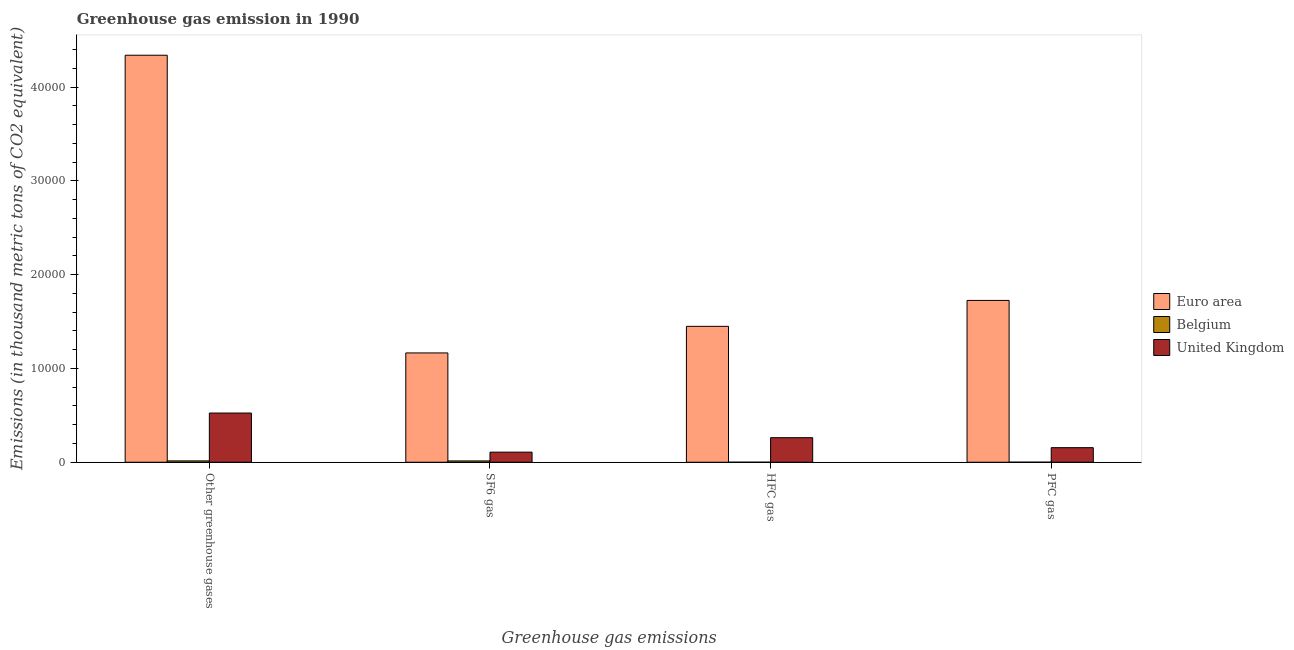How many different coloured bars are there?
Provide a succinct answer. 3. Are the number of bars on each tick of the X-axis equal?
Provide a succinct answer. Yes. How many bars are there on the 2nd tick from the left?
Your answer should be compact. 3. What is the label of the 1st group of bars from the left?
Your answer should be very brief. Other greenhouse gases. What is the emission of greenhouse gases in Euro area?
Ensure brevity in your answer.  4.34e+04. Across all countries, what is the maximum emission of hfc gas?
Provide a short and direct response. 1.45e+04. Across all countries, what is the minimum emission of greenhouse gases?
Make the answer very short. 141.9. In which country was the emission of greenhouse gases minimum?
Provide a short and direct response. Belgium. What is the total emission of sf6 gas in the graph?
Offer a very short reply. 1.29e+04. What is the difference between the emission of greenhouse gases in United Kingdom and that in Belgium?
Offer a very short reply. 5102.3. What is the difference between the emission of hfc gas in United Kingdom and the emission of pfc gas in Euro area?
Give a very brief answer. -1.46e+04. What is the average emission of greenhouse gases per country?
Your answer should be compact. 1.63e+04. What is the difference between the emission of hfc gas and emission of pfc gas in Belgium?
Ensure brevity in your answer.  -2.4. In how many countries, is the emission of greenhouse gases greater than 30000 thousand metric tons?
Keep it short and to the point. 1. What is the ratio of the emission of hfc gas in Belgium to that in United Kingdom?
Your response must be concise. 0. Is the emission of pfc gas in Belgium less than that in United Kingdom?
Your answer should be very brief. Yes. Is the difference between the emission of greenhouse gases in Belgium and United Kingdom greater than the difference between the emission of pfc gas in Belgium and United Kingdom?
Keep it short and to the point. No. What is the difference between the highest and the second highest emission of pfc gas?
Ensure brevity in your answer.  1.57e+04. What is the difference between the highest and the lowest emission of pfc gas?
Your response must be concise. 1.73e+04. In how many countries, is the emission of greenhouse gases greater than the average emission of greenhouse gases taken over all countries?
Provide a succinct answer. 1. Is it the case that in every country, the sum of the emission of hfc gas and emission of pfc gas is greater than the sum of emission of greenhouse gases and emission of sf6 gas?
Your answer should be compact. No. What does the 3rd bar from the left in PFC gas represents?
Your answer should be very brief. United Kingdom. What does the 1st bar from the right in Other greenhouse gases represents?
Provide a succinct answer. United Kingdom. Are all the bars in the graph horizontal?
Provide a succinct answer. No. Are the values on the major ticks of Y-axis written in scientific E-notation?
Provide a short and direct response. No. Does the graph contain any zero values?
Your answer should be very brief. No. What is the title of the graph?
Make the answer very short. Greenhouse gas emission in 1990. Does "Marshall Islands" appear as one of the legend labels in the graph?
Offer a very short reply. No. What is the label or title of the X-axis?
Give a very brief answer. Greenhouse gas emissions. What is the label or title of the Y-axis?
Give a very brief answer. Emissions (in thousand metric tons of CO2 equivalent). What is the Emissions (in thousand metric tons of CO2 equivalent) in Euro area in Other greenhouse gases?
Your answer should be compact. 4.34e+04. What is the Emissions (in thousand metric tons of CO2 equivalent) of Belgium in Other greenhouse gases?
Give a very brief answer. 141.9. What is the Emissions (in thousand metric tons of CO2 equivalent) of United Kingdom in Other greenhouse gases?
Give a very brief answer. 5244.2. What is the Emissions (in thousand metric tons of CO2 equivalent) in Euro area in SF6 gas?
Offer a terse response. 1.17e+04. What is the Emissions (in thousand metric tons of CO2 equivalent) of Belgium in SF6 gas?
Ensure brevity in your answer.  138.5. What is the Emissions (in thousand metric tons of CO2 equivalent) in United Kingdom in SF6 gas?
Give a very brief answer. 1073.9. What is the Emissions (in thousand metric tons of CO2 equivalent) in Euro area in HFC gas?
Offer a very short reply. 1.45e+04. What is the Emissions (in thousand metric tons of CO2 equivalent) of Belgium in HFC gas?
Your answer should be very brief. 0.5. What is the Emissions (in thousand metric tons of CO2 equivalent) in United Kingdom in HFC gas?
Make the answer very short. 2617.8. What is the Emissions (in thousand metric tons of CO2 equivalent) in Euro area in PFC gas?
Offer a terse response. 1.73e+04. What is the Emissions (in thousand metric tons of CO2 equivalent) of Belgium in PFC gas?
Your answer should be compact. 2.9. What is the Emissions (in thousand metric tons of CO2 equivalent) in United Kingdom in PFC gas?
Offer a terse response. 1552.5. Across all Greenhouse gas emissions, what is the maximum Emissions (in thousand metric tons of CO2 equivalent) of Euro area?
Keep it short and to the point. 4.34e+04. Across all Greenhouse gas emissions, what is the maximum Emissions (in thousand metric tons of CO2 equivalent) in Belgium?
Keep it short and to the point. 141.9. Across all Greenhouse gas emissions, what is the maximum Emissions (in thousand metric tons of CO2 equivalent) of United Kingdom?
Make the answer very short. 5244.2. Across all Greenhouse gas emissions, what is the minimum Emissions (in thousand metric tons of CO2 equivalent) in Euro area?
Offer a terse response. 1.17e+04. Across all Greenhouse gas emissions, what is the minimum Emissions (in thousand metric tons of CO2 equivalent) in United Kingdom?
Provide a succinct answer. 1073.9. What is the total Emissions (in thousand metric tons of CO2 equivalent) of Euro area in the graph?
Make the answer very short. 8.68e+04. What is the total Emissions (in thousand metric tons of CO2 equivalent) in Belgium in the graph?
Make the answer very short. 283.8. What is the total Emissions (in thousand metric tons of CO2 equivalent) of United Kingdom in the graph?
Keep it short and to the point. 1.05e+04. What is the difference between the Emissions (in thousand metric tons of CO2 equivalent) of Euro area in Other greenhouse gases and that in SF6 gas?
Ensure brevity in your answer.  3.17e+04. What is the difference between the Emissions (in thousand metric tons of CO2 equivalent) of Belgium in Other greenhouse gases and that in SF6 gas?
Provide a succinct answer. 3.4. What is the difference between the Emissions (in thousand metric tons of CO2 equivalent) in United Kingdom in Other greenhouse gases and that in SF6 gas?
Keep it short and to the point. 4170.3. What is the difference between the Emissions (in thousand metric tons of CO2 equivalent) of Euro area in Other greenhouse gases and that in HFC gas?
Offer a terse response. 2.89e+04. What is the difference between the Emissions (in thousand metric tons of CO2 equivalent) of Belgium in Other greenhouse gases and that in HFC gas?
Offer a very short reply. 141.4. What is the difference between the Emissions (in thousand metric tons of CO2 equivalent) of United Kingdom in Other greenhouse gases and that in HFC gas?
Make the answer very short. 2626.4. What is the difference between the Emissions (in thousand metric tons of CO2 equivalent) of Euro area in Other greenhouse gases and that in PFC gas?
Provide a succinct answer. 2.61e+04. What is the difference between the Emissions (in thousand metric tons of CO2 equivalent) in Belgium in Other greenhouse gases and that in PFC gas?
Ensure brevity in your answer.  139. What is the difference between the Emissions (in thousand metric tons of CO2 equivalent) in United Kingdom in Other greenhouse gases and that in PFC gas?
Make the answer very short. 3691.7. What is the difference between the Emissions (in thousand metric tons of CO2 equivalent) in Euro area in SF6 gas and that in HFC gas?
Provide a succinct answer. -2837. What is the difference between the Emissions (in thousand metric tons of CO2 equivalent) in Belgium in SF6 gas and that in HFC gas?
Ensure brevity in your answer.  138. What is the difference between the Emissions (in thousand metric tons of CO2 equivalent) of United Kingdom in SF6 gas and that in HFC gas?
Provide a short and direct response. -1543.9. What is the difference between the Emissions (in thousand metric tons of CO2 equivalent) in Euro area in SF6 gas and that in PFC gas?
Offer a terse response. -5600.5. What is the difference between the Emissions (in thousand metric tons of CO2 equivalent) in Belgium in SF6 gas and that in PFC gas?
Provide a short and direct response. 135.6. What is the difference between the Emissions (in thousand metric tons of CO2 equivalent) in United Kingdom in SF6 gas and that in PFC gas?
Keep it short and to the point. -478.6. What is the difference between the Emissions (in thousand metric tons of CO2 equivalent) in Euro area in HFC gas and that in PFC gas?
Your answer should be compact. -2763.5. What is the difference between the Emissions (in thousand metric tons of CO2 equivalent) in United Kingdom in HFC gas and that in PFC gas?
Offer a very short reply. 1065.3. What is the difference between the Emissions (in thousand metric tons of CO2 equivalent) in Euro area in Other greenhouse gases and the Emissions (in thousand metric tons of CO2 equivalent) in Belgium in SF6 gas?
Make the answer very short. 4.33e+04. What is the difference between the Emissions (in thousand metric tons of CO2 equivalent) in Euro area in Other greenhouse gases and the Emissions (in thousand metric tons of CO2 equivalent) in United Kingdom in SF6 gas?
Offer a very short reply. 4.23e+04. What is the difference between the Emissions (in thousand metric tons of CO2 equivalent) in Belgium in Other greenhouse gases and the Emissions (in thousand metric tons of CO2 equivalent) in United Kingdom in SF6 gas?
Offer a terse response. -932. What is the difference between the Emissions (in thousand metric tons of CO2 equivalent) of Euro area in Other greenhouse gases and the Emissions (in thousand metric tons of CO2 equivalent) of Belgium in HFC gas?
Give a very brief answer. 4.34e+04. What is the difference between the Emissions (in thousand metric tons of CO2 equivalent) in Euro area in Other greenhouse gases and the Emissions (in thousand metric tons of CO2 equivalent) in United Kingdom in HFC gas?
Ensure brevity in your answer.  4.08e+04. What is the difference between the Emissions (in thousand metric tons of CO2 equivalent) in Belgium in Other greenhouse gases and the Emissions (in thousand metric tons of CO2 equivalent) in United Kingdom in HFC gas?
Ensure brevity in your answer.  -2475.9. What is the difference between the Emissions (in thousand metric tons of CO2 equivalent) of Euro area in Other greenhouse gases and the Emissions (in thousand metric tons of CO2 equivalent) of Belgium in PFC gas?
Provide a succinct answer. 4.34e+04. What is the difference between the Emissions (in thousand metric tons of CO2 equivalent) in Euro area in Other greenhouse gases and the Emissions (in thousand metric tons of CO2 equivalent) in United Kingdom in PFC gas?
Ensure brevity in your answer.  4.18e+04. What is the difference between the Emissions (in thousand metric tons of CO2 equivalent) in Belgium in Other greenhouse gases and the Emissions (in thousand metric tons of CO2 equivalent) in United Kingdom in PFC gas?
Make the answer very short. -1410.6. What is the difference between the Emissions (in thousand metric tons of CO2 equivalent) of Euro area in SF6 gas and the Emissions (in thousand metric tons of CO2 equivalent) of Belgium in HFC gas?
Offer a terse response. 1.17e+04. What is the difference between the Emissions (in thousand metric tons of CO2 equivalent) of Euro area in SF6 gas and the Emissions (in thousand metric tons of CO2 equivalent) of United Kingdom in HFC gas?
Offer a very short reply. 9036.8. What is the difference between the Emissions (in thousand metric tons of CO2 equivalent) in Belgium in SF6 gas and the Emissions (in thousand metric tons of CO2 equivalent) in United Kingdom in HFC gas?
Provide a short and direct response. -2479.3. What is the difference between the Emissions (in thousand metric tons of CO2 equivalent) of Euro area in SF6 gas and the Emissions (in thousand metric tons of CO2 equivalent) of Belgium in PFC gas?
Provide a succinct answer. 1.17e+04. What is the difference between the Emissions (in thousand metric tons of CO2 equivalent) in Euro area in SF6 gas and the Emissions (in thousand metric tons of CO2 equivalent) in United Kingdom in PFC gas?
Make the answer very short. 1.01e+04. What is the difference between the Emissions (in thousand metric tons of CO2 equivalent) of Belgium in SF6 gas and the Emissions (in thousand metric tons of CO2 equivalent) of United Kingdom in PFC gas?
Make the answer very short. -1414. What is the difference between the Emissions (in thousand metric tons of CO2 equivalent) of Euro area in HFC gas and the Emissions (in thousand metric tons of CO2 equivalent) of Belgium in PFC gas?
Provide a succinct answer. 1.45e+04. What is the difference between the Emissions (in thousand metric tons of CO2 equivalent) in Euro area in HFC gas and the Emissions (in thousand metric tons of CO2 equivalent) in United Kingdom in PFC gas?
Your answer should be very brief. 1.29e+04. What is the difference between the Emissions (in thousand metric tons of CO2 equivalent) in Belgium in HFC gas and the Emissions (in thousand metric tons of CO2 equivalent) in United Kingdom in PFC gas?
Your response must be concise. -1552. What is the average Emissions (in thousand metric tons of CO2 equivalent) in Euro area per Greenhouse gas emissions?
Ensure brevity in your answer.  2.17e+04. What is the average Emissions (in thousand metric tons of CO2 equivalent) of Belgium per Greenhouse gas emissions?
Keep it short and to the point. 70.95. What is the average Emissions (in thousand metric tons of CO2 equivalent) in United Kingdom per Greenhouse gas emissions?
Your response must be concise. 2622.1. What is the difference between the Emissions (in thousand metric tons of CO2 equivalent) in Euro area and Emissions (in thousand metric tons of CO2 equivalent) in Belgium in Other greenhouse gases?
Keep it short and to the point. 4.33e+04. What is the difference between the Emissions (in thousand metric tons of CO2 equivalent) in Euro area and Emissions (in thousand metric tons of CO2 equivalent) in United Kingdom in Other greenhouse gases?
Your answer should be very brief. 3.82e+04. What is the difference between the Emissions (in thousand metric tons of CO2 equivalent) of Belgium and Emissions (in thousand metric tons of CO2 equivalent) of United Kingdom in Other greenhouse gases?
Provide a short and direct response. -5102.3. What is the difference between the Emissions (in thousand metric tons of CO2 equivalent) of Euro area and Emissions (in thousand metric tons of CO2 equivalent) of Belgium in SF6 gas?
Your answer should be compact. 1.15e+04. What is the difference between the Emissions (in thousand metric tons of CO2 equivalent) of Euro area and Emissions (in thousand metric tons of CO2 equivalent) of United Kingdom in SF6 gas?
Ensure brevity in your answer.  1.06e+04. What is the difference between the Emissions (in thousand metric tons of CO2 equivalent) in Belgium and Emissions (in thousand metric tons of CO2 equivalent) in United Kingdom in SF6 gas?
Make the answer very short. -935.4. What is the difference between the Emissions (in thousand metric tons of CO2 equivalent) in Euro area and Emissions (in thousand metric tons of CO2 equivalent) in Belgium in HFC gas?
Ensure brevity in your answer.  1.45e+04. What is the difference between the Emissions (in thousand metric tons of CO2 equivalent) of Euro area and Emissions (in thousand metric tons of CO2 equivalent) of United Kingdom in HFC gas?
Provide a short and direct response. 1.19e+04. What is the difference between the Emissions (in thousand metric tons of CO2 equivalent) of Belgium and Emissions (in thousand metric tons of CO2 equivalent) of United Kingdom in HFC gas?
Keep it short and to the point. -2617.3. What is the difference between the Emissions (in thousand metric tons of CO2 equivalent) of Euro area and Emissions (in thousand metric tons of CO2 equivalent) of Belgium in PFC gas?
Ensure brevity in your answer.  1.73e+04. What is the difference between the Emissions (in thousand metric tons of CO2 equivalent) in Euro area and Emissions (in thousand metric tons of CO2 equivalent) in United Kingdom in PFC gas?
Ensure brevity in your answer.  1.57e+04. What is the difference between the Emissions (in thousand metric tons of CO2 equivalent) in Belgium and Emissions (in thousand metric tons of CO2 equivalent) in United Kingdom in PFC gas?
Your response must be concise. -1549.6. What is the ratio of the Emissions (in thousand metric tons of CO2 equivalent) of Euro area in Other greenhouse gases to that in SF6 gas?
Your answer should be very brief. 3.72. What is the ratio of the Emissions (in thousand metric tons of CO2 equivalent) of Belgium in Other greenhouse gases to that in SF6 gas?
Give a very brief answer. 1.02. What is the ratio of the Emissions (in thousand metric tons of CO2 equivalent) of United Kingdom in Other greenhouse gases to that in SF6 gas?
Your answer should be very brief. 4.88. What is the ratio of the Emissions (in thousand metric tons of CO2 equivalent) in Euro area in Other greenhouse gases to that in HFC gas?
Your answer should be compact. 2.99. What is the ratio of the Emissions (in thousand metric tons of CO2 equivalent) in Belgium in Other greenhouse gases to that in HFC gas?
Your answer should be compact. 283.8. What is the ratio of the Emissions (in thousand metric tons of CO2 equivalent) in United Kingdom in Other greenhouse gases to that in HFC gas?
Your response must be concise. 2. What is the ratio of the Emissions (in thousand metric tons of CO2 equivalent) in Euro area in Other greenhouse gases to that in PFC gas?
Offer a terse response. 2.52. What is the ratio of the Emissions (in thousand metric tons of CO2 equivalent) in Belgium in Other greenhouse gases to that in PFC gas?
Your answer should be very brief. 48.93. What is the ratio of the Emissions (in thousand metric tons of CO2 equivalent) in United Kingdom in Other greenhouse gases to that in PFC gas?
Offer a very short reply. 3.38. What is the ratio of the Emissions (in thousand metric tons of CO2 equivalent) in Euro area in SF6 gas to that in HFC gas?
Keep it short and to the point. 0.8. What is the ratio of the Emissions (in thousand metric tons of CO2 equivalent) of Belgium in SF6 gas to that in HFC gas?
Make the answer very short. 277. What is the ratio of the Emissions (in thousand metric tons of CO2 equivalent) in United Kingdom in SF6 gas to that in HFC gas?
Give a very brief answer. 0.41. What is the ratio of the Emissions (in thousand metric tons of CO2 equivalent) in Euro area in SF6 gas to that in PFC gas?
Offer a very short reply. 0.68. What is the ratio of the Emissions (in thousand metric tons of CO2 equivalent) of Belgium in SF6 gas to that in PFC gas?
Your answer should be compact. 47.76. What is the ratio of the Emissions (in thousand metric tons of CO2 equivalent) of United Kingdom in SF6 gas to that in PFC gas?
Make the answer very short. 0.69. What is the ratio of the Emissions (in thousand metric tons of CO2 equivalent) in Euro area in HFC gas to that in PFC gas?
Provide a short and direct response. 0.84. What is the ratio of the Emissions (in thousand metric tons of CO2 equivalent) of Belgium in HFC gas to that in PFC gas?
Your answer should be compact. 0.17. What is the ratio of the Emissions (in thousand metric tons of CO2 equivalent) in United Kingdom in HFC gas to that in PFC gas?
Ensure brevity in your answer.  1.69. What is the difference between the highest and the second highest Emissions (in thousand metric tons of CO2 equivalent) of Euro area?
Provide a succinct answer. 2.61e+04. What is the difference between the highest and the second highest Emissions (in thousand metric tons of CO2 equivalent) in United Kingdom?
Offer a very short reply. 2626.4. What is the difference between the highest and the lowest Emissions (in thousand metric tons of CO2 equivalent) in Euro area?
Your answer should be compact. 3.17e+04. What is the difference between the highest and the lowest Emissions (in thousand metric tons of CO2 equivalent) in Belgium?
Provide a short and direct response. 141.4. What is the difference between the highest and the lowest Emissions (in thousand metric tons of CO2 equivalent) in United Kingdom?
Provide a short and direct response. 4170.3. 